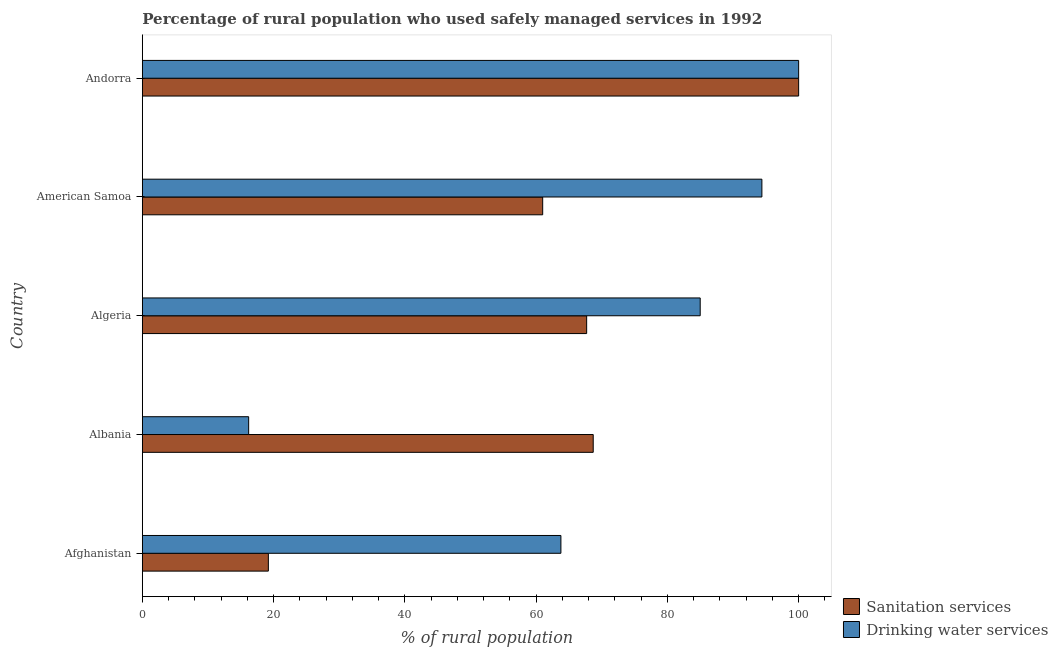How many different coloured bars are there?
Provide a succinct answer. 2. Are the number of bars on each tick of the Y-axis equal?
Your response must be concise. Yes. How many bars are there on the 1st tick from the top?
Make the answer very short. 2. How many bars are there on the 4th tick from the bottom?
Make the answer very short. 2. What is the label of the 2nd group of bars from the top?
Provide a short and direct response. American Samoa. In how many cases, is the number of bars for a given country not equal to the number of legend labels?
Your answer should be compact. 0. What is the percentage of rural population who used sanitation services in Albania?
Provide a succinct answer. 68.7. In which country was the percentage of rural population who used drinking water services maximum?
Offer a very short reply. Andorra. In which country was the percentage of rural population who used sanitation services minimum?
Offer a very short reply. Afghanistan. What is the total percentage of rural population who used drinking water services in the graph?
Make the answer very short. 359.38. What is the difference between the percentage of rural population who used drinking water services in Albania and that in Algeria?
Provide a short and direct response. -68.8. What is the difference between the percentage of rural population who used drinking water services in Albania and the percentage of rural population who used sanitation services in American Samoa?
Your response must be concise. -44.8. What is the average percentage of rural population who used sanitation services per country?
Your answer should be very brief. 63.32. What is the ratio of the percentage of rural population who used sanitation services in Afghanistan to that in American Samoa?
Offer a very short reply. 0.32. Is the difference between the percentage of rural population who used sanitation services in Afghanistan and Algeria greater than the difference between the percentage of rural population who used drinking water services in Afghanistan and Algeria?
Give a very brief answer. No. What is the difference between the highest and the second highest percentage of rural population who used drinking water services?
Make the answer very short. 5.6. What is the difference between the highest and the lowest percentage of rural population who used drinking water services?
Ensure brevity in your answer.  83.8. In how many countries, is the percentage of rural population who used drinking water services greater than the average percentage of rural population who used drinking water services taken over all countries?
Your answer should be compact. 3. Is the sum of the percentage of rural population who used drinking water services in Algeria and American Samoa greater than the maximum percentage of rural population who used sanitation services across all countries?
Make the answer very short. Yes. What does the 1st bar from the top in American Samoa represents?
Your response must be concise. Drinking water services. What does the 2nd bar from the bottom in Afghanistan represents?
Ensure brevity in your answer.  Drinking water services. How many bars are there?
Make the answer very short. 10. Are all the bars in the graph horizontal?
Offer a very short reply. Yes. What is the difference between two consecutive major ticks on the X-axis?
Provide a succinct answer. 20. Does the graph contain any zero values?
Offer a very short reply. No. Where does the legend appear in the graph?
Ensure brevity in your answer.  Bottom right. How many legend labels are there?
Give a very brief answer. 2. What is the title of the graph?
Your answer should be very brief. Percentage of rural population who used safely managed services in 1992. What is the label or title of the X-axis?
Your answer should be very brief. % of rural population. What is the label or title of the Y-axis?
Your response must be concise. Country. What is the % of rural population of Sanitation services in Afghanistan?
Provide a succinct answer. 19.2. What is the % of rural population in Drinking water services in Afghanistan?
Keep it short and to the point. 63.78. What is the % of rural population in Sanitation services in Albania?
Your answer should be very brief. 68.7. What is the % of rural population of Drinking water services in Albania?
Your answer should be compact. 16.2. What is the % of rural population of Sanitation services in Algeria?
Keep it short and to the point. 67.7. What is the % of rural population in Drinking water services in American Samoa?
Provide a succinct answer. 94.4. What is the % of rural population in Drinking water services in Andorra?
Your answer should be very brief. 100. Across all countries, what is the maximum % of rural population in Sanitation services?
Offer a very short reply. 100. Across all countries, what is the maximum % of rural population of Drinking water services?
Offer a terse response. 100. What is the total % of rural population in Sanitation services in the graph?
Make the answer very short. 316.6. What is the total % of rural population of Drinking water services in the graph?
Offer a very short reply. 359.38. What is the difference between the % of rural population of Sanitation services in Afghanistan and that in Albania?
Your answer should be very brief. -49.5. What is the difference between the % of rural population in Drinking water services in Afghanistan and that in Albania?
Offer a terse response. 47.58. What is the difference between the % of rural population in Sanitation services in Afghanistan and that in Algeria?
Your answer should be compact. -48.5. What is the difference between the % of rural population in Drinking water services in Afghanistan and that in Algeria?
Offer a terse response. -21.22. What is the difference between the % of rural population of Sanitation services in Afghanistan and that in American Samoa?
Your answer should be compact. -41.8. What is the difference between the % of rural population in Drinking water services in Afghanistan and that in American Samoa?
Keep it short and to the point. -30.62. What is the difference between the % of rural population of Sanitation services in Afghanistan and that in Andorra?
Your answer should be compact. -80.8. What is the difference between the % of rural population in Drinking water services in Afghanistan and that in Andorra?
Offer a very short reply. -36.22. What is the difference between the % of rural population of Drinking water services in Albania and that in Algeria?
Offer a terse response. -68.8. What is the difference between the % of rural population in Drinking water services in Albania and that in American Samoa?
Offer a terse response. -78.2. What is the difference between the % of rural population of Sanitation services in Albania and that in Andorra?
Your answer should be compact. -31.3. What is the difference between the % of rural population in Drinking water services in Albania and that in Andorra?
Provide a short and direct response. -83.8. What is the difference between the % of rural population of Drinking water services in Algeria and that in American Samoa?
Your response must be concise. -9.4. What is the difference between the % of rural population in Sanitation services in Algeria and that in Andorra?
Make the answer very short. -32.3. What is the difference between the % of rural population of Sanitation services in American Samoa and that in Andorra?
Make the answer very short. -39. What is the difference between the % of rural population in Drinking water services in American Samoa and that in Andorra?
Give a very brief answer. -5.6. What is the difference between the % of rural population in Sanitation services in Afghanistan and the % of rural population in Drinking water services in Algeria?
Keep it short and to the point. -65.8. What is the difference between the % of rural population in Sanitation services in Afghanistan and the % of rural population in Drinking water services in American Samoa?
Provide a succinct answer. -75.2. What is the difference between the % of rural population of Sanitation services in Afghanistan and the % of rural population of Drinking water services in Andorra?
Offer a very short reply. -80.8. What is the difference between the % of rural population of Sanitation services in Albania and the % of rural population of Drinking water services in Algeria?
Provide a short and direct response. -16.3. What is the difference between the % of rural population in Sanitation services in Albania and the % of rural population in Drinking water services in American Samoa?
Give a very brief answer. -25.7. What is the difference between the % of rural population of Sanitation services in Albania and the % of rural population of Drinking water services in Andorra?
Make the answer very short. -31.3. What is the difference between the % of rural population of Sanitation services in Algeria and the % of rural population of Drinking water services in American Samoa?
Give a very brief answer. -26.7. What is the difference between the % of rural population of Sanitation services in Algeria and the % of rural population of Drinking water services in Andorra?
Your response must be concise. -32.3. What is the difference between the % of rural population of Sanitation services in American Samoa and the % of rural population of Drinking water services in Andorra?
Ensure brevity in your answer.  -39. What is the average % of rural population of Sanitation services per country?
Offer a very short reply. 63.32. What is the average % of rural population of Drinking water services per country?
Your response must be concise. 71.88. What is the difference between the % of rural population of Sanitation services and % of rural population of Drinking water services in Afghanistan?
Provide a succinct answer. -44.58. What is the difference between the % of rural population of Sanitation services and % of rural population of Drinking water services in Albania?
Your answer should be very brief. 52.5. What is the difference between the % of rural population in Sanitation services and % of rural population in Drinking water services in Algeria?
Your answer should be very brief. -17.3. What is the difference between the % of rural population in Sanitation services and % of rural population in Drinking water services in American Samoa?
Provide a short and direct response. -33.4. What is the ratio of the % of rural population of Sanitation services in Afghanistan to that in Albania?
Ensure brevity in your answer.  0.28. What is the ratio of the % of rural population in Drinking water services in Afghanistan to that in Albania?
Make the answer very short. 3.94. What is the ratio of the % of rural population in Sanitation services in Afghanistan to that in Algeria?
Provide a short and direct response. 0.28. What is the ratio of the % of rural population in Drinking water services in Afghanistan to that in Algeria?
Provide a short and direct response. 0.75. What is the ratio of the % of rural population of Sanitation services in Afghanistan to that in American Samoa?
Provide a short and direct response. 0.31. What is the ratio of the % of rural population in Drinking water services in Afghanistan to that in American Samoa?
Keep it short and to the point. 0.68. What is the ratio of the % of rural population of Sanitation services in Afghanistan to that in Andorra?
Offer a very short reply. 0.19. What is the ratio of the % of rural population in Drinking water services in Afghanistan to that in Andorra?
Offer a terse response. 0.64. What is the ratio of the % of rural population in Sanitation services in Albania to that in Algeria?
Offer a terse response. 1.01. What is the ratio of the % of rural population in Drinking water services in Albania to that in Algeria?
Give a very brief answer. 0.19. What is the ratio of the % of rural population of Sanitation services in Albania to that in American Samoa?
Your response must be concise. 1.13. What is the ratio of the % of rural population of Drinking water services in Albania to that in American Samoa?
Provide a succinct answer. 0.17. What is the ratio of the % of rural population of Sanitation services in Albania to that in Andorra?
Make the answer very short. 0.69. What is the ratio of the % of rural population of Drinking water services in Albania to that in Andorra?
Make the answer very short. 0.16. What is the ratio of the % of rural population in Sanitation services in Algeria to that in American Samoa?
Your answer should be very brief. 1.11. What is the ratio of the % of rural population in Drinking water services in Algeria to that in American Samoa?
Offer a very short reply. 0.9. What is the ratio of the % of rural population in Sanitation services in Algeria to that in Andorra?
Ensure brevity in your answer.  0.68. What is the ratio of the % of rural population in Drinking water services in Algeria to that in Andorra?
Your response must be concise. 0.85. What is the ratio of the % of rural population of Sanitation services in American Samoa to that in Andorra?
Ensure brevity in your answer.  0.61. What is the ratio of the % of rural population in Drinking water services in American Samoa to that in Andorra?
Ensure brevity in your answer.  0.94. What is the difference between the highest and the second highest % of rural population in Sanitation services?
Make the answer very short. 31.3. What is the difference between the highest and the second highest % of rural population of Drinking water services?
Make the answer very short. 5.6. What is the difference between the highest and the lowest % of rural population of Sanitation services?
Provide a short and direct response. 80.8. What is the difference between the highest and the lowest % of rural population in Drinking water services?
Ensure brevity in your answer.  83.8. 